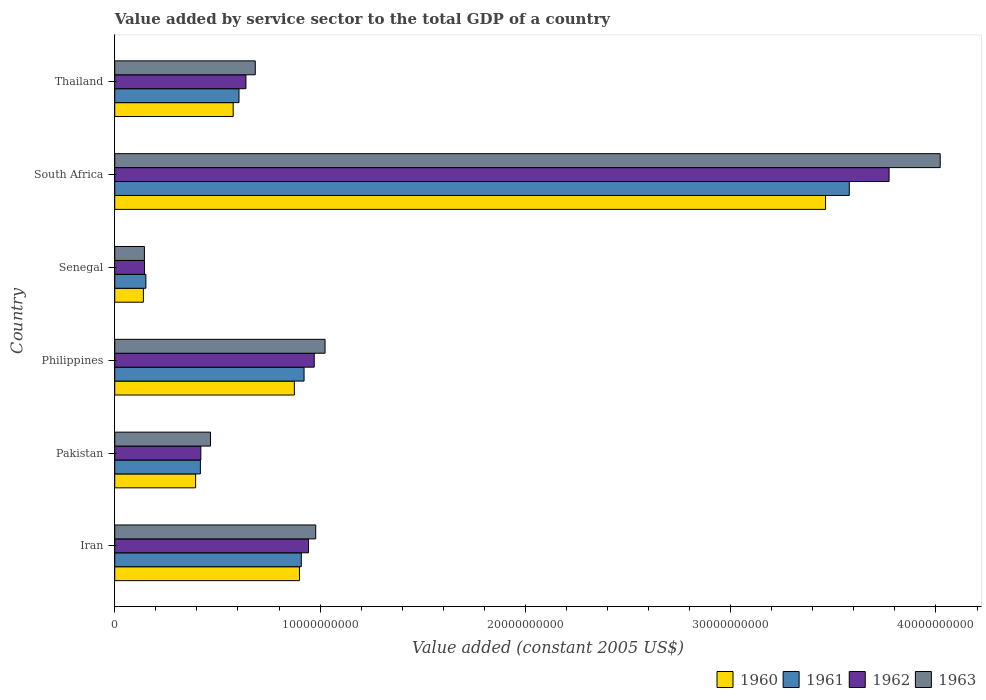How many different coloured bars are there?
Ensure brevity in your answer.  4. What is the label of the 3rd group of bars from the top?
Your answer should be compact. Senegal. What is the value added by service sector in 1963 in Thailand?
Make the answer very short. 6.84e+09. Across all countries, what is the maximum value added by service sector in 1960?
Provide a succinct answer. 3.46e+1. Across all countries, what is the minimum value added by service sector in 1962?
Keep it short and to the point. 1.45e+09. In which country was the value added by service sector in 1960 maximum?
Your answer should be very brief. South Africa. In which country was the value added by service sector in 1962 minimum?
Your answer should be compact. Senegal. What is the total value added by service sector in 1961 in the graph?
Your answer should be very brief. 6.58e+1. What is the difference between the value added by service sector in 1961 in Pakistan and that in Philippines?
Offer a terse response. -5.05e+09. What is the difference between the value added by service sector in 1962 in South Africa and the value added by service sector in 1960 in Philippines?
Provide a short and direct response. 2.90e+1. What is the average value added by service sector in 1963 per country?
Offer a very short reply. 1.22e+1. What is the difference between the value added by service sector in 1962 and value added by service sector in 1961 in Thailand?
Your answer should be very brief. 3.39e+08. In how many countries, is the value added by service sector in 1962 greater than 16000000000 US$?
Your answer should be very brief. 1. What is the ratio of the value added by service sector in 1962 in Pakistan to that in Philippines?
Make the answer very short. 0.43. Is the difference between the value added by service sector in 1962 in Pakistan and Senegal greater than the difference between the value added by service sector in 1961 in Pakistan and Senegal?
Make the answer very short. Yes. What is the difference between the highest and the second highest value added by service sector in 1962?
Give a very brief answer. 2.80e+1. What is the difference between the highest and the lowest value added by service sector in 1960?
Offer a very short reply. 3.32e+1. Is the sum of the value added by service sector in 1961 in Iran and Thailand greater than the maximum value added by service sector in 1960 across all countries?
Give a very brief answer. No. Are all the bars in the graph horizontal?
Ensure brevity in your answer.  Yes. What is the difference between two consecutive major ticks on the X-axis?
Your answer should be compact. 1.00e+1. Are the values on the major ticks of X-axis written in scientific E-notation?
Give a very brief answer. No. Does the graph contain grids?
Ensure brevity in your answer.  No. Where does the legend appear in the graph?
Give a very brief answer. Bottom right. How are the legend labels stacked?
Offer a terse response. Horizontal. What is the title of the graph?
Ensure brevity in your answer.  Value added by service sector to the total GDP of a country. What is the label or title of the X-axis?
Give a very brief answer. Value added (constant 2005 US$). What is the label or title of the Y-axis?
Your answer should be very brief. Country. What is the Value added (constant 2005 US$) of 1960 in Iran?
Provide a short and direct response. 9.00e+09. What is the Value added (constant 2005 US$) in 1961 in Iran?
Ensure brevity in your answer.  9.09e+09. What is the Value added (constant 2005 US$) in 1962 in Iran?
Ensure brevity in your answer.  9.44e+09. What is the Value added (constant 2005 US$) in 1963 in Iran?
Keep it short and to the point. 9.79e+09. What is the Value added (constant 2005 US$) of 1960 in Pakistan?
Your answer should be very brief. 3.94e+09. What is the Value added (constant 2005 US$) in 1961 in Pakistan?
Provide a short and direct response. 4.17e+09. What is the Value added (constant 2005 US$) in 1962 in Pakistan?
Give a very brief answer. 4.19e+09. What is the Value added (constant 2005 US$) in 1963 in Pakistan?
Provide a succinct answer. 4.66e+09. What is the Value added (constant 2005 US$) in 1960 in Philippines?
Your answer should be very brief. 8.75e+09. What is the Value added (constant 2005 US$) in 1961 in Philippines?
Offer a terse response. 9.22e+09. What is the Value added (constant 2005 US$) in 1962 in Philippines?
Keep it short and to the point. 9.72e+09. What is the Value added (constant 2005 US$) of 1963 in Philippines?
Provide a short and direct response. 1.02e+1. What is the Value added (constant 2005 US$) in 1960 in Senegal?
Your answer should be very brief. 1.39e+09. What is the Value added (constant 2005 US$) of 1961 in Senegal?
Make the answer very short. 1.52e+09. What is the Value added (constant 2005 US$) in 1962 in Senegal?
Ensure brevity in your answer.  1.45e+09. What is the Value added (constant 2005 US$) of 1963 in Senegal?
Your response must be concise. 1.44e+09. What is the Value added (constant 2005 US$) of 1960 in South Africa?
Your answer should be very brief. 3.46e+1. What is the Value added (constant 2005 US$) of 1961 in South Africa?
Your response must be concise. 3.58e+1. What is the Value added (constant 2005 US$) of 1962 in South Africa?
Ensure brevity in your answer.  3.77e+1. What is the Value added (constant 2005 US$) in 1963 in South Africa?
Your answer should be very brief. 4.02e+1. What is the Value added (constant 2005 US$) of 1960 in Thailand?
Offer a very short reply. 5.77e+09. What is the Value added (constant 2005 US$) of 1961 in Thailand?
Keep it short and to the point. 6.05e+09. What is the Value added (constant 2005 US$) of 1962 in Thailand?
Give a very brief answer. 6.39e+09. What is the Value added (constant 2005 US$) of 1963 in Thailand?
Offer a very short reply. 6.84e+09. Across all countries, what is the maximum Value added (constant 2005 US$) in 1960?
Provide a short and direct response. 3.46e+1. Across all countries, what is the maximum Value added (constant 2005 US$) in 1961?
Provide a short and direct response. 3.58e+1. Across all countries, what is the maximum Value added (constant 2005 US$) of 1962?
Your response must be concise. 3.77e+1. Across all countries, what is the maximum Value added (constant 2005 US$) in 1963?
Offer a terse response. 4.02e+1. Across all countries, what is the minimum Value added (constant 2005 US$) in 1960?
Keep it short and to the point. 1.39e+09. Across all countries, what is the minimum Value added (constant 2005 US$) in 1961?
Make the answer very short. 1.52e+09. Across all countries, what is the minimum Value added (constant 2005 US$) in 1962?
Give a very brief answer. 1.45e+09. Across all countries, what is the minimum Value added (constant 2005 US$) of 1963?
Provide a succinct answer. 1.44e+09. What is the total Value added (constant 2005 US$) of 1960 in the graph?
Offer a very short reply. 6.35e+1. What is the total Value added (constant 2005 US$) in 1961 in the graph?
Offer a very short reply. 6.58e+1. What is the total Value added (constant 2005 US$) in 1962 in the graph?
Your response must be concise. 6.89e+1. What is the total Value added (constant 2005 US$) in 1963 in the graph?
Ensure brevity in your answer.  7.32e+1. What is the difference between the Value added (constant 2005 US$) of 1960 in Iran and that in Pakistan?
Give a very brief answer. 5.06e+09. What is the difference between the Value added (constant 2005 US$) of 1961 in Iran and that in Pakistan?
Your response must be concise. 4.92e+09. What is the difference between the Value added (constant 2005 US$) in 1962 in Iran and that in Pakistan?
Offer a terse response. 5.24e+09. What is the difference between the Value added (constant 2005 US$) of 1963 in Iran and that in Pakistan?
Your answer should be very brief. 5.12e+09. What is the difference between the Value added (constant 2005 US$) of 1960 in Iran and that in Philippines?
Offer a very short reply. 2.49e+08. What is the difference between the Value added (constant 2005 US$) in 1961 in Iran and that in Philippines?
Give a very brief answer. -1.35e+08. What is the difference between the Value added (constant 2005 US$) of 1962 in Iran and that in Philippines?
Give a very brief answer. -2.80e+08. What is the difference between the Value added (constant 2005 US$) in 1963 in Iran and that in Philippines?
Ensure brevity in your answer.  -4.54e+08. What is the difference between the Value added (constant 2005 US$) in 1960 in Iran and that in Senegal?
Your answer should be compact. 7.60e+09. What is the difference between the Value added (constant 2005 US$) of 1961 in Iran and that in Senegal?
Provide a short and direct response. 7.57e+09. What is the difference between the Value added (constant 2005 US$) of 1962 in Iran and that in Senegal?
Keep it short and to the point. 7.99e+09. What is the difference between the Value added (constant 2005 US$) in 1963 in Iran and that in Senegal?
Offer a terse response. 8.34e+09. What is the difference between the Value added (constant 2005 US$) of 1960 in Iran and that in South Africa?
Provide a short and direct response. -2.56e+1. What is the difference between the Value added (constant 2005 US$) in 1961 in Iran and that in South Africa?
Your answer should be compact. -2.67e+1. What is the difference between the Value added (constant 2005 US$) of 1962 in Iran and that in South Africa?
Provide a short and direct response. -2.83e+1. What is the difference between the Value added (constant 2005 US$) in 1963 in Iran and that in South Africa?
Provide a succinct answer. -3.04e+1. What is the difference between the Value added (constant 2005 US$) of 1960 in Iran and that in Thailand?
Your response must be concise. 3.23e+09. What is the difference between the Value added (constant 2005 US$) of 1961 in Iran and that in Thailand?
Offer a very short reply. 3.03e+09. What is the difference between the Value added (constant 2005 US$) of 1962 in Iran and that in Thailand?
Your answer should be very brief. 3.05e+09. What is the difference between the Value added (constant 2005 US$) of 1963 in Iran and that in Thailand?
Your answer should be compact. 2.94e+09. What is the difference between the Value added (constant 2005 US$) of 1960 in Pakistan and that in Philippines?
Provide a succinct answer. -4.81e+09. What is the difference between the Value added (constant 2005 US$) of 1961 in Pakistan and that in Philippines?
Your answer should be compact. -5.05e+09. What is the difference between the Value added (constant 2005 US$) of 1962 in Pakistan and that in Philippines?
Provide a succinct answer. -5.52e+09. What is the difference between the Value added (constant 2005 US$) of 1963 in Pakistan and that in Philippines?
Your answer should be very brief. -5.58e+09. What is the difference between the Value added (constant 2005 US$) of 1960 in Pakistan and that in Senegal?
Offer a terse response. 2.54e+09. What is the difference between the Value added (constant 2005 US$) of 1961 in Pakistan and that in Senegal?
Provide a short and direct response. 2.65e+09. What is the difference between the Value added (constant 2005 US$) in 1962 in Pakistan and that in Senegal?
Your answer should be very brief. 2.74e+09. What is the difference between the Value added (constant 2005 US$) in 1963 in Pakistan and that in Senegal?
Provide a short and direct response. 3.22e+09. What is the difference between the Value added (constant 2005 US$) in 1960 in Pakistan and that in South Africa?
Provide a succinct answer. -3.07e+1. What is the difference between the Value added (constant 2005 US$) in 1961 in Pakistan and that in South Africa?
Provide a short and direct response. -3.16e+1. What is the difference between the Value added (constant 2005 US$) in 1962 in Pakistan and that in South Africa?
Ensure brevity in your answer.  -3.35e+1. What is the difference between the Value added (constant 2005 US$) in 1963 in Pakistan and that in South Africa?
Offer a very short reply. -3.55e+1. What is the difference between the Value added (constant 2005 US$) of 1960 in Pakistan and that in Thailand?
Your answer should be very brief. -1.83e+09. What is the difference between the Value added (constant 2005 US$) in 1961 in Pakistan and that in Thailand?
Offer a terse response. -1.88e+09. What is the difference between the Value added (constant 2005 US$) in 1962 in Pakistan and that in Thailand?
Ensure brevity in your answer.  -2.20e+09. What is the difference between the Value added (constant 2005 US$) of 1963 in Pakistan and that in Thailand?
Give a very brief answer. -2.18e+09. What is the difference between the Value added (constant 2005 US$) of 1960 in Philippines and that in Senegal?
Your answer should be compact. 7.35e+09. What is the difference between the Value added (constant 2005 US$) of 1961 in Philippines and that in Senegal?
Your response must be concise. 7.70e+09. What is the difference between the Value added (constant 2005 US$) of 1962 in Philippines and that in Senegal?
Keep it short and to the point. 8.27e+09. What is the difference between the Value added (constant 2005 US$) in 1963 in Philippines and that in Senegal?
Give a very brief answer. 8.80e+09. What is the difference between the Value added (constant 2005 US$) in 1960 in Philippines and that in South Africa?
Your response must be concise. -2.59e+1. What is the difference between the Value added (constant 2005 US$) in 1961 in Philippines and that in South Africa?
Your answer should be very brief. -2.66e+1. What is the difference between the Value added (constant 2005 US$) of 1962 in Philippines and that in South Africa?
Your answer should be compact. -2.80e+1. What is the difference between the Value added (constant 2005 US$) in 1963 in Philippines and that in South Africa?
Offer a terse response. -3.00e+1. What is the difference between the Value added (constant 2005 US$) in 1960 in Philippines and that in Thailand?
Your response must be concise. 2.98e+09. What is the difference between the Value added (constant 2005 US$) in 1961 in Philippines and that in Thailand?
Keep it short and to the point. 3.17e+09. What is the difference between the Value added (constant 2005 US$) in 1962 in Philippines and that in Thailand?
Keep it short and to the point. 3.33e+09. What is the difference between the Value added (constant 2005 US$) of 1963 in Philippines and that in Thailand?
Give a very brief answer. 3.40e+09. What is the difference between the Value added (constant 2005 US$) of 1960 in Senegal and that in South Africa?
Provide a succinct answer. -3.32e+1. What is the difference between the Value added (constant 2005 US$) of 1961 in Senegal and that in South Africa?
Ensure brevity in your answer.  -3.43e+1. What is the difference between the Value added (constant 2005 US$) of 1962 in Senegal and that in South Africa?
Offer a very short reply. -3.63e+1. What is the difference between the Value added (constant 2005 US$) in 1963 in Senegal and that in South Africa?
Your answer should be compact. -3.88e+1. What is the difference between the Value added (constant 2005 US$) in 1960 in Senegal and that in Thailand?
Provide a succinct answer. -4.37e+09. What is the difference between the Value added (constant 2005 US$) in 1961 in Senegal and that in Thailand?
Give a very brief answer. -4.53e+09. What is the difference between the Value added (constant 2005 US$) of 1962 in Senegal and that in Thailand?
Make the answer very short. -4.94e+09. What is the difference between the Value added (constant 2005 US$) in 1963 in Senegal and that in Thailand?
Provide a short and direct response. -5.40e+09. What is the difference between the Value added (constant 2005 US$) in 1960 in South Africa and that in Thailand?
Keep it short and to the point. 2.89e+1. What is the difference between the Value added (constant 2005 US$) of 1961 in South Africa and that in Thailand?
Provide a succinct answer. 2.97e+1. What is the difference between the Value added (constant 2005 US$) in 1962 in South Africa and that in Thailand?
Your answer should be compact. 3.13e+1. What is the difference between the Value added (constant 2005 US$) of 1963 in South Africa and that in Thailand?
Offer a very short reply. 3.34e+1. What is the difference between the Value added (constant 2005 US$) in 1960 in Iran and the Value added (constant 2005 US$) in 1961 in Pakistan?
Your response must be concise. 4.83e+09. What is the difference between the Value added (constant 2005 US$) of 1960 in Iran and the Value added (constant 2005 US$) of 1962 in Pakistan?
Your response must be concise. 4.80e+09. What is the difference between the Value added (constant 2005 US$) in 1960 in Iran and the Value added (constant 2005 US$) in 1963 in Pakistan?
Provide a short and direct response. 4.33e+09. What is the difference between the Value added (constant 2005 US$) of 1961 in Iran and the Value added (constant 2005 US$) of 1962 in Pakistan?
Give a very brief answer. 4.89e+09. What is the difference between the Value added (constant 2005 US$) of 1961 in Iran and the Value added (constant 2005 US$) of 1963 in Pakistan?
Your answer should be compact. 4.42e+09. What is the difference between the Value added (constant 2005 US$) in 1962 in Iran and the Value added (constant 2005 US$) in 1963 in Pakistan?
Give a very brief answer. 4.77e+09. What is the difference between the Value added (constant 2005 US$) in 1960 in Iran and the Value added (constant 2005 US$) in 1961 in Philippines?
Give a very brief answer. -2.24e+08. What is the difference between the Value added (constant 2005 US$) in 1960 in Iran and the Value added (constant 2005 US$) in 1962 in Philippines?
Your response must be concise. -7.19e+08. What is the difference between the Value added (constant 2005 US$) in 1960 in Iran and the Value added (constant 2005 US$) in 1963 in Philippines?
Make the answer very short. -1.25e+09. What is the difference between the Value added (constant 2005 US$) in 1961 in Iran and the Value added (constant 2005 US$) in 1962 in Philippines?
Offer a very short reply. -6.30e+08. What is the difference between the Value added (constant 2005 US$) of 1961 in Iran and the Value added (constant 2005 US$) of 1963 in Philippines?
Keep it short and to the point. -1.16e+09. What is the difference between the Value added (constant 2005 US$) in 1962 in Iran and the Value added (constant 2005 US$) in 1963 in Philippines?
Your answer should be compact. -8.07e+08. What is the difference between the Value added (constant 2005 US$) in 1960 in Iran and the Value added (constant 2005 US$) in 1961 in Senegal?
Your answer should be compact. 7.48e+09. What is the difference between the Value added (constant 2005 US$) of 1960 in Iran and the Value added (constant 2005 US$) of 1962 in Senegal?
Your response must be concise. 7.55e+09. What is the difference between the Value added (constant 2005 US$) in 1960 in Iran and the Value added (constant 2005 US$) in 1963 in Senegal?
Make the answer very short. 7.55e+09. What is the difference between the Value added (constant 2005 US$) of 1961 in Iran and the Value added (constant 2005 US$) of 1962 in Senegal?
Provide a succinct answer. 7.64e+09. What is the difference between the Value added (constant 2005 US$) of 1961 in Iran and the Value added (constant 2005 US$) of 1963 in Senegal?
Give a very brief answer. 7.64e+09. What is the difference between the Value added (constant 2005 US$) in 1962 in Iran and the Value added (constant 2005 US$) in 1963 in Senegal?
Make the answer very short. 7.99e+09. What is the difference between the Value added (constant 2005 US$) of 1960 in Iran and the Value added (constant 2005 US$) of 1961 in South Africa?
Provide a succinct answer. -2.68e+1. What is the difference between the Value added (constant 2005 US$) in 1960 in Iran and the Value added (constant 2005 US$) in 1962 in South Africa?
Your answer should be compact. -2.87e+1. What is the difference between the Value added (constant 2005 US$) in 1960 in Iran and the Value added (constant 2005 US$) in 1963 in South Africa?
Your response must be concise. -3.12e+1. What is the difference between the Value added (constant 2005 US$) in 1961 in Iran and the Value added (constant 2005 US$) in 1962 in South Africa?
Keep it short and to the point. -2.86e+1. What is the difference between the Value added (constant 2005 US$) in 1961 in Iran and the Value added (constant 2005 US$) in 1963 in South Africa?
Make the answer very short. -3.11e+1. What is the difference between the Value added (constant 2005 US$) of 1962 in Iran and the Value added (constant 2005 US$) of 1963 in South Africa?
Offer a very short reply. -3.08e+1. What is the difference between the Value added (constant 2005 US$) of 1960 in Iran and the Value added (constant 2005 US$) of 1961 in Thailand?
Your response must be concise. 2.95e+09. What is the difference between the Value added (constant 2005 US$) of 1960 in Iran and the Value added (constant 2005 US$) of 1962 in Thailand?
Ensure brevity in your answer.  2.61e+09. What is the difference between the Value added (constant 2005 US$) in 1960 in Iran and the Value added (constant 2005 US$) in 1963 in Thailand?
Your response must be concise. 2.15e+09. What is the difference between the Value added (constant 2005 US$) in 1961 in Iran and the Value added (constant 2005 US$) in 1962 in Thailand?
Provide a short and direct response. 2.70e+09. What is the difference between the Value added (constant 2005 US$) of 1961 in Iran and the Value added (constant 2005 US$) of 1963 in Thailand?
Give a very brief answer. 2.24e+09. What is the difference between the Value added (constant 2005 US$) in 1962 in Iran and the Value added (constant 2005 US$) in 1963 in Thailand?
Your response must be concise. 2.59e+09. What is the difference between the Value added (constant 2005 US$) of 1960 in Pakistan and the Value added (constant 2005 US$) of 1961 in Philippines?
Offer a very short reply. -5.28e+09. What is the difference between the Value added (constant 2005 US$) of 1960 in Pakistan and the Value added (constant 2005 US$) of 1962 in Philippines?
Offer a very short reply. -5.78e+09. What is the difference between the Value added (constant 2005 US$) in 1960 in Pakistan and the Value added (constant 2005 US$) in 1963 in Philippines?
Offer a terse response. -6.30e+09. What is the difference between the Value added (constant 2005 US$) in 1961 in Pakistan and the Value added (constant 2005 US$) in 1962 in Philippines?
Provide a short and direct response. -5.55e+09. What is the difference between the Value added (constant 2005 US$) in 1961 in Pakistan and the Value added (constant 2005 US$) in 1963 in Philippines?
Keep it short and to the point. -6.07e+09. What is the difference between the Value added (constant 2005 US$) of 1962 in Pakistan and the Value added (constant 2005 US$) of 1963 in Philippines?
Your answer should be very brief. -6.05e+09. What is the difference between the Value added (constant 2005 US$) of 1960 in Pakistan and the Value added (constant 2005 US$) of 1961 in Senegal?
Offer a terse response. 2.42e+09. What is the difference between the Value added (constant 2005 US$) in 1960 in Pakistan and the Value added (constant 2005 US$) in 1962 in Senegal?
Give a very brief answer. 2.49e+09. What is the difference between the Value added (constant 2005 US$) in 1960 in Pakistan and the Value added (constant 2005 US$) in 1963 in Senegal?
Offer a very short reply. 2.49e+09. What is the difference between the Value added (constant 2005 US$) of 1961 in Pakistan and the Value added (constant 2005 US$) of 1962 in Senegal?
Provide a succinct answer. 2.72e+09. What is the difference between the Value added (constant 2005 US$) of 1961 in Pakistan and the Value added (constant 2005 US$) of 1963 in Senegal?
Provide a succinct answer. 2.73e+09. What is the difference between the Value added (constant 2005 US$) of 1962 in Pakistan and the Value added (constant 2005 US$) of 1963 in Senegal?
Your answer should be very brief. 2.75e+09. What is the difference between the Value added (constant 2005 US$) in 1960 in Pakistan and the Value added (constant 2005 US$) in 1961 in South Africa?
Make the answer very short. -3.18e+1. What is the difference between the Value added (constant 2005 US$) of 1960 in Pakistan and the Value added (constant 2005 US$) of 1962 in South Africa?
Offer a very short reply. -3.38e+1. What is the difference between the Value added (constant 2005 US$) of 1960 in Pakistan and the Value added (constant 2005 US$) of 1963 in South Africa?
Ensure brevity in your answer.  -3.63e+1. What is the difference between the Value added (constant 2005 US$) in 1961 in Pakistan and the Value added (constant 2005 US$) in 1962 in South Africa?
Offer a very short reply. -3.35e+1. What is the difference between the Value added (constant 2005 US$) of 1961 in Pakistan and the Value added (constant 2005 US$) of 1963 in South Africa?
Offer a very short reply. -3.60e+1. What is the difference between the Value added (constant 2005 US$) of 1962 in Pakistan and the Value added (constant 2005 US$) of 1963 in South Africa?
Provide a succinct answer. -3.60e+1. What is the difference between the Value added (constant 2005 US$) in 1960 in Pakistan and the Value added (constant 2005 US$) in 1961 in Thailand?
Offer a terse response. -2.11e+09. What is the difference between the Value added (constant 2005 US$) in 1960 in Pakistan and the Value added (constant 2005 US$) in 1962 in Thailand?
Keep it short and to the point. -2.45e+09. What is the difference between the Value added (constant 2005 US$) in 1960 in Pakistan and the Value added (constant 2005 US$) in 1963 in Thailand?
Give a very brief answer. -2.91e+09. What is the difference between the Value added (constant 2005 US$) in 1961 in Pakistan and the Value added (constant 2005 US$) in 1962 in Thailand?
Provide a short and direct response. -2.22e+09. What is the difference between the Value added (constant 2005 US$) in 1961 in Pakistan and the Value added (constant 2005 US$) in 1963 in Thailand?
Provide a short and direct response. -2.67e+09. What is the difference between the Value added (constant 2005 US$) of 1962 in Pakistan and the Value added (constant 2005 US$) of 1963 in Thailand?
Ensure brevity in your answer.  -2.65e+09. What is the difference between the Value added (constant 2005 US$) of 1960 in Philippines and the Value added (constant 2005 US$) of 1961 in Senegal?
Keep it short and to the point. 7.23e+09. What is the difference between the Value added (constant 2005 US$) of 1960 in Philippines and the Value added (constant 2005 US$) of 1962 in Senegal?
Provide a short and direct response. 7.30e+09. What is the difference between the Value added (constant 2005 US$) in 1960 in Philippines and the Value added (constant 2005 US$) in 1963 in Senegal?
Your response must be concise. 7.30e+09. What is the difference between the Value added (constant 2005 US$) of 1961 in Philippines and the Value added (constant 2005 US$) of 1962 in Senegal?
Your answer should be very brief. 7.77e+09. What is the difference between the Value added (constant 2005 US$) in 1961 in Philippines and the Value added (constant 2005 US$) in 1963 in Senegal?
Keep it short and to the point. 7.78e+09. What is the difference between the Value added (constant 2005 US$) in 1962 in Philippines and the Value added (constant 2005 US$) in 1963 in Senegal?
Make the answer very short. 8.27e+09. What is the difference between the Value added (constant 2005 US$) in 1960 in Philippines and the Value added (constant 2005 US$) in 1961 in South Africa?
Keep it short and to the point. -2.70e+1. What is the difference between the Value added (constant 2005 US$) of 1960 in Philippines and the Value added (constant 2005 US$) of 1962 in South Africa?
Offer a very short reply. -2.90e+1. What is the difference between the Value added (constant 2005 US$) of 1960 in Philippines and the Value added (constant 2005 US$) of 1963 in South Africa?
Your answer should be compact. -3.15e+1. What is the difference between the Value added (constant 2005 US$) of 1961 in Philippines and the Value added (constant 2005 US$) of 1962 in South Africa?
Make the answer very short. -2.85e+1. What is the difference between the Value added (constant 2005 US$) in 1961 in Philippines and the Value added (constant 2005 US$) in 1963 in South Africa?
Keep it short and to the point. -3.10e+1. What is the difference between the Value added (constant 2005 US$) in 1962 in Philippines and the Value added (constant 2005 US$) in 1963 in South Africa?
Provide a succinct answer. -3.05e+1. What is the difference between the Value added (constant 2005 US$) in 1960 in Philippines and the Value added (constant 2005 US$) in 1961 in Thailand?
Offer a very short reply. 2.70e+09. What is the difference between the Value added (constant 2005 US$) of 1960 in Philippines and the Value added (constant 2005 US$) of 1962 in Thailand?
Offer a terse response. 2.36e+09. What is the difference between the Value added (constant 2005 US$) of 1960 in Philippines and the Value added (constant 2005 US$) of 1963 in Thailand?
Your response must be concise. 1.90e+09. What is the difference between the Value added (constant 2005 US$) in 1961 in Philippines and the Value added (constant 2005 US$) in 1962 in Thailand?
Your response must be concise. 2.83e+09. What is the difference between the Value added (constant 2005 US$) in 1961 in Philippines and the Value added (constant 2005 US$) in 1963 in Thailand?
Offer a terse response. 2.38e+09. What is the difference between the Value added (constant 2005 US$) of 1962 in Philippines and the Value added (constant 2005 US$) of 1963 in Thailand?
Make the answer very short. 2.87e+09. What is the difference between the Value added (constant 2005 US$) of 1960 in Senegal and the Value added (constant 2005 US$) of 1961 in South Africa?
Offer a very short reply. -3.44e+1. What is the difference between the Value added (constant 2005 US$) in 1960 in Senegal and the Value added (constant 2005 US$) in 1962 in South Africa?
Offer a terse response. -3.63e+1. What is the difference between the Value added (constant 2005 US$) in 1960 in Senegal and the Value added (constant 2005 US$) in 1963 in South Africa?
Provide a short and direct response. -3.88e+1. What is the difference between the Value added (constant 2005 US$) of 1961 in Senegal and the Value added (constant 2005 US$) of 1962 in South Africa?
Give a very brief answer. -3.62e+1. What is the difference between the Value added (constant 2005 US$) of 1961 in Senegal and the Value added (constant 2005 US$) of 1963 in South Africa?
Provide a short and direct response. -3.87e+1. What is the difference between the Value added (constant 2005 US$) of 1962 in Senegal and the Value added (constant 2005 US$) of 1963 in South Africa?
Give a very brief answer. -3.88e+1. What is the difference between the Value added (constant 2005 US$) of 1960 in Senegal and the Value added (constant 2005 US$) of 1961 in Thailand?
Offer a terse response. -4.66e+09. What is the difference between the Value added (constant 2005 US$) of 1960 in Senegal and the Value added (constant 2005 US$) of 1962 in Thailand?
Give a very brief answer. -5.00e+09. What is the difference between the Value added (constant 2005 US$) of 1960 in Senegal and the Value added (constant 2005 US$) of 1963 in Thailand?
Your response must be concise. -5.45e+09. What is the difference between the Value added (constant 2005 US$) of 1961 in Senegal and the Value added (constant 2005 US$) of 1962 in Thailand?
Your response must be concise. -4.87e+09. What is the difference between the Value added (constant 2005 US$) of 1961 in Senegal and the Value added (constant 2005 US$) of 1963 in Thailand?
Keep it short and to the point. -5.33e+09. What is the difference between the Value added (constant 2005 US$) of 1962 in Senegal and the Value added (constant 2005 US$) of 1963 in Thailand?
Ensure brevity in your answer.  -5.39e+09. What is the difference between the Value added (constant 2005 US$) in 1960 in South Africa and the Value added (constant 2005 US$) in 1961 in Thailand?
Keep it short and to the point. 2.86e+1. What is the difference between the Value added (constant 2005 US$) in 1960 in South Africa and the Value added (constant 2005 US$) in 1962 in Thailand?
Keep it short and to the point. 2.82e+1. What is the difference between the Value added (constant 2005 US$) of 1960 in South Africa and the Value added (constant 2005 US$) of 1963 in Thailand?
Offer a very short reply. 2.78e+1. What is the difference between the Value added (constant 2005 US$) in 1961 in South Africa and the Value added (constant 2005 US$) in 1962 in Thailand?
Keep it short and to the point. 2.94e+1. What is the difference between the Value added (constant 2005 US$) in 1961 in South Africa and the Value added (constant 2005 US$) in 1963 in Thailand?
Give a very brief answer. 2.89e+1. What is the difference between the Value added (constant 2005 US$) of 1962 in South Africa and the Value added (constant 2005 US$) of 1963 in Thailand?
Make the answer very short. 3.09e+1. What is the average Value added (constant 2005 US$) of 1960 per country?
Your answer should be compact. 1.06e+1. What is the average Value added (constant 2005 US$) of 1961 per country?
Provide a succinct answer. 1.10e+1. What is the average Value added (constant 2005 US$) of 1962 per country?
Keep it short and to the point. 1.15e+1. What is the average Value added (constant 2005 US$) of 1963 per country?
Offer a terse response. 1.22e+1. What is the difference between the Value added (constant 2005 US$) in 1960 and Value added (constant 2005 US$) in 1961 in Iran?
Your response must be concise. -8.88e+07. What is the difference between the Value added (constant 2005 US$) of 1960 and Value added (constant 2005 US$) of 1962 in Iran?
Make the answer very short. -4.39e+08. What is the difference between the Value added (constant 2005 US$) in 1960 and Value added (constant 2005 US$) in 1963 in Iran?
Your answer should be very brief. -7.91e+08. What is the difference between the Value added (constant 2005 US$) of 1961 and Value added (constant 2005 US$) of 1962 in Iran?
Your response must be concise. -3.50e+08. What is the difference between the Value added (constant 2005 US$) in 1961 and Value added (constant 2005 US$) in 1963 in Iran?
Provide a short and direct response. -7.02e+08. What is the difference between the Value added (constant 2005 US$) of 1962 and Value added (constant 2005 US$) of 1963 in Iran?
Your response must be concise. -3.52e+08. What is the difference between the Value added (constant 2005 US$) in 1960 and Value added (constant 2005 US$) in 1961 in Pakistan?
Provide a short and direct response. -2.32e+08. What is the difference between the Value added (constant 2005 US$) of 1960 and Value added (constant 2005 US$) of 1962 in Pakistan?
Make the answer very short. -2.54e+08. What is the difference between the Value added (constant 2005 US$) of 1960 and Value added (constant 2005 US$) of 1963 in Pakistan?
Ensure brevity in your answer.  -7.25e+08. What is the difference between the Value added (constant 2005 US$) of 1961 and Value added (constant 2005 US$) of 1962 in Pakistan?
Keep it short and to the point. -2.26e+07. What is the difference between the Value added (constant 2005 US$) in 1961 and Value added (constant 2005 US$) in 1963 in Pakistan?
Your answer should be very brief. -4.93e+08. What is the difference between the Value added (constant 2005 US$) in 1962 and Value added (constant 2005 US$) in 1963 in Pakistan?
Provide a short and direct response. -4.71e+08. What is the difference between the Value added (constant 2005 US$) of 1960 and Value added (constant 2005 US$) of 1961 in Philippines?
Your answer should be very brief. -4.73e+08. What is the difference between the Value added (constant 2005 US$) of 1960 and Value added (constant 2005 US$) of 1962 in Philippines?
Make the answer very short. -9.68e+08. What is the difference between the Value added (constant 2005 US$) of 1960 and Value added (constant 2005 US$) of 1963 in Philippines?
Your answer should be very brief. -1.49e+09. What is the difference between the Value added (constant 2005 US$) in 1961 and Value added (constant 2005 US$) in 1962 in Philippines?
Your answer should be very brief. -4.95e+08. What is the difference between the Value added (constant 2005 US$) in 1961 and Value added (constant 2005 US$) in 1963 in Philippines?
Ensure brevity in your answer.  -1.02e+09. What is the difference between the Value added (constant 2005 US$) of 1962 and Value added (constant 2005 US$) of 1963 in Philippines?
Offer a very short reply. -5.27e+08. What is the difference between the Value added (constant 2005 US$) in 1960 and Value added (constant 2005 US$) in 1961 in Senegal?
Make the answer very short. -1.22e+08. What is the difference between the Value added (constant 2005 US$) in 1960 and Value added (constant 2005 US$) in 1962 in Senegal?
Your response must be concise. -5.52e+07. What is the difference between the Value added (constant 2005 US$) of 1960 and Value added (constant 2005 US$) of 1963 in Senegal?
Keep it short and to the point. -4.94e+07. What is the difference between the Value added (constant 2005 US$) in 1961 and Value added (constant 2005 US$) in 1962 in Senegal?
Give a very brief answer. 6.67e+07. What is the difference between the Value added (constant 2005 US$) of 1961 and Value added (constant 2005 US$) of 1963 in Senegal?
Keep it short and to the point. 7.25e+07. What is the difference between the Value added (constant 2005 US$) in 1962 and Value added (constant 2005 US$) in 1963 in Senegal?
Provide a short and direct response. 5.77e+06. What is the difference between the Value added (constant 2005 US$) of 1960 and Value added (constant 2005 US$) of 1961 in South Africa?
Provide a succinct answer. -1.16e+09. What is the difference between the Value added (constant 2005 US$) of 1960 and Value added (constant 2005 US$) of 1962 in South Africa?
Make the answer very short. -3.09e+09. What is the difference between the Value added (constant 2005 US$) in 1960 and Value added (constant 2005 US$) in 1963 in South Africa?
Make the answer very short. -5.58e+09. What is the difference between the Value added (constant 2005 US$) of 1961 and Value added (constant 2005 US$) of 1962 in South Africa?
Offer a very short reply. -1.94e+09. What is the difference between the Value added (constant 2005 US$) of 1961 and Value added (constant 2005 US$) of 1963 in South Africa?
Offer a terse response. -4.43e+09. What is the difference between the Value added (constant 2005 US$) in 1962 and Value added (constant 2005 US$) in 1963 in South Africa?
Keep it short and to the point. -2.49e+09. What is the difference between the Value added (constant 2005 US$) of 1960 and Value added (constant 2005 US$) of 1961 in Thailand?
Your answer should be very brief. -2.83e+08. What is the difference between the Value added (constant 2005 US$) in 1960 and Value added (constant 2005 US$) in 1962 in Thailand?
Offer a very short reply. -6.21e+08. What is the difference between the Value added (constant 2005 US$) in 1960 and Value added (constant 2005 US$) in 1963 in Thailand?
Give a very brief answer. -1.08e+09. What is the difference between the Value added (constant 2005 US$) in 1961 and Value added (constant 2005 US$) in 1962 in Thailand?
Give a very brief answer. -3.39e+08. What is the difference between the Value added (constant 2005 US$) of 1961 and Value added (constant 2005 US$) of 1963 in Thailand?
Provide a short and direct response. -7.93e+08. What is the difference between the Value added (constant 2005 US$) of 1962 and Value added (constant 2005 US$) of 1963 in Thailand?
Provide a short and direct response. -4.54e+08. What is the ratio of the Value added (constant 2005 US$) of 1960 in Iran to that in Pakistan?
Offer a terse response. 2.28. What is the ratio of the Value added (constant 2005 US$) in 1961 in Iran to that in Pakistan?
Provide a short and direct response. 2.18. What is the ratio of the Value added (constant 2005 US$) of 1962 in Iran to that in Pakistan?
Offer a very short reply. 2.25. What is the ratio of the Value added (constant 2005 US$) in 1963 in Iran to that in Pakistan?
Offer a terse response. 2.1. What is the ratio of the Value added (constant 2005 US$) in 1960 in Iran to that in Philippines?
Make the answer very short. 1.03. What is the ratio of the Value added (constant 2005 US$) in 1961 in Iran to that in Philippines?
Make the answer very short. 0.99. What is the ratio of the Value added (constant 2005 US$) in 1962 in Iran to that in Philippines?
Keep it short and to the point. 0.97. What is the ratio of the Value added (constant 2005 US$) of 1963 in Iran to that in Philippines?
Provide a short and direct response. 0.96. What is the ratio of the Value added (constant 2005 US$) in 1960 in Iran to that in Senegal?
Make the answer very short. 6.45. What is the ratio of the Value added (constant 2005 US$) in 1961 in Iran to that in Senegal?
Your answer should be very brief. 5.99. What is the ratio of the Value added (constant 2005 US$) of 1962 in Iran to that in Senegal?
Provide a succinct answer. 6.51. What is the ratio of the Value added (constant 2005 US$) in 1963 in Iran to that in Senegal?
Provide a succinct answer. 6.78. What is the ratio of the Value added (constant 2005 US$) in 1960 in Iran to that in South Africa?
Provide a short and direct response. 0.26. What is the ratio of the Value added (constant 2005 US$) of 1961 in Iran to that in South Africa?
Offer a very short reply. 0.25. What is the ratio of the Value added (constant 2005 US$) in 1962 in Iran to that in South Africa?
Your response must be concise. 0.25. What is the ratio of the Value added (constant 2005 US$) in 1963 in Iran to that in South Africa?
Give a very brief answer. 0.24. What is the ratio of the Value added (constant 2005 US$) in 1960 in Iran to that in Thailand?
Provide a succinct answer. 1.56. What is the ratio of the Value added (constant 2005 US$) in 1961 in Iran to that in Thailand?
Ensure brevity in your answer.  1.5. What is the ratio of the Value added (constant 2005 US$) of 1962 in Iran to that in Thailand?
Provide a short and direct response. 1.48. What is the ratio of the Value added (constant 2005 US$) in 1963 in Iran to that in Thailand?
Offer a very short reply. 1.43. What is the ratio of the Value added (constant 2005 US$) in 1960 in Pakistan to that in Philippines?
Make the answer very short. 0.45. What is the ratio of the Value added (constant 2005 US$) in 1961 in Pakistan to that in Philippines?
Offer a very short reply. 0.45. What is the ratio of the Value added (constant 2005 US$) of 1962 in Pakistan to that in Philippines?
Give a very brief answer. 0.43. What is the ratio of the Value added (constant 2005 US$) in 1963 in Pakistan to that in Philippines?
Offer a terse response. 0.46. What is the ratio of the Value added (constant 2005 US$) in 1960 in Pakistan to that in Senegal?
Give a very brief answer. 2.82. What is the ratio of the Value added (constant 2005 US$) of 1961 in Pakistan to that in Senegal?
Keep it short and to the point. 2.75. What is the ratio of the Value added (constant 2005 US$) of 1962 in Pakistan to that in Senegal?
Make the answer very short. 2.89. What is the ratio of the Value added (constant 2005 US$) of 1963 in Pakistan to that in Senegal?
Offer a very short reply. 3.23. What is the ratio of the Value added (constant 2005 US$) in 1960 in Pakistan to that in South Africa?
Ensure brevity in your answer.  0.11. What is the ratio of the Value added (constant 2005 US$) of 1961 in Pakistan to that in South Africa?
Offer a terse response. 0.12. What is the ratio of the Value added (constant 2005 US$) of 1962 in Pakistan to that in South Africa?
Make the answer very short. 0.11. What is the ratio of the Value added (constant 2005 US$) of 1963 in Pakistan to that in South Africa?
Offer a very short reply. 0.12. What is the ratio of the Value added (constant 2005 US$) of 1960 in Pakistan to that in Thailand?
Offer a terse response. 0.68. What is the ratio of the Value added (constant 2005 US$) of 1961 in Pakistan to that in Thailand?
Offer a terse response. 0.69. What is the ratio of the Value added (constant 2005 US$) in 1962 in Pakistan to that in Thailand?
Provide a succinct answer. 0.66. What is the ratio of the Value added (constant 2005 US$) in 1963 in Pakistan to that in Thailand?
Your answer should be very brief. 0.68. What is the ratio of the Value added (constant 2005 US$) in 1960 in Philippines to that in Senegal?
Keep it short and to the point. 6.27. What is the ratio of the Value added (constant 2005 US$) of 1961 in Philippines to that in Senegal?
Provide a short and direct response. 6.08. What is the ratio of the Value added (constant 2005 US$) in 1962 in Philippines to that in Senegal?
Provide a succinct answer. 6.7. What is the ratio of the Value added (constant 2005 US$) of 1963 in Philippines to that in Senegal?
Ensure brevity in your answer.  7.09. What is the ratio of the Value added (constant 2005 US$) in 1960 in Philippines to that in South Africa?
Provide a succinct answer. 0.25. What is the ratio of the Value added (constant 2005 US$) in 1961 in Philippines to that in South Africa?
Ensure brevity in your answer.  0.26. What is the ratio of the Value added (constant 2005 US$) in 1962 in Philippines to that in South Africa?
Offer a terse response. 0.26. What is the ratio of the Value added (constant 2005 US$) of 1963 in Philippines to that in South Africa?
Provide a succinct answer. 0.25. What is the ratio of the Value added (constant 2005 US$) in 1960 in Philippines to that in Thailand?
Provide a short and direct response. 1.52. What is the ratio of the Value added (constant 2005 US$) in 1961 in Philippines to that in Thailand?
Provide a succinct answer. 1.52. What is the ratio of the Value added (constant 2005 US$) in 1962 in Philippines to that in Thailand?
Your response must be concise. 1.52. What is the ratio of the Value added (constant 2005 US$) in 1963 in Philippines to that in Thailand?
Your answer should be very brief. 1.5. What is the ratio of the Value added (constant 2005 US$) in 1960 in Senegal to that in South Africa?
Your response must be concise. 0.04. What is the ratio of the Value added (constant 2005 US$) in 1961 in Senegal to that in South Africa?
Your response must be concise. 0.04. What is the ratio of the Value added (constant 2005 US$) of 1962 in Senegal to that in South Africa?
Your response must be concise. 0.04. What is the ratio of the Value added (constant 2005 US$) in 1963 in Senegal to that in South Africa?
Your answer should be very brief. 0.04. What is the ratio of the Value added (constant 2005 US$) in 1960 in Senegal to that in Thailand?
Give a very brief answer. 0.24. What is the ratio of the Value added (constant 2005 US$) in 1961 in Senegal to that in Thailand?
Offer a terse response. 0.25. What is the ratio of the Value added (constant 2005 US$) in 1962 in Senegal to that in Thailand?
Provide a succinct answer. 0.23. What is the ratio of the Value added (constant 2005 US$) of 1963 in Senegal to that in Thailand?
Ensure brevity in your answer.  0.21. What is the ratio of the Value added (constant 2005 US$) in 1960 in South Africa to that in Thailand?
Your answer should be very brief. 6. What is the ratio of the Value added (constant 2005 US$) in 1961 in South Africa to that in Thailand?
Make the answer very short. 5.91. What is the ratio of the Value added (constant 2005 US$) in 1962 in South Africa to that in Thailand?
Provide a succinct answer. 5.9. What is the ratio of the Value added (constant 2005 US$) of 1963 in South Africa to that in Thailand?
Your response must be concise. 5.87. What is the difference between the highest and the second highest Value added (constant 2005 US$) of 1960?
Keep it short and to the point. 2.56e+1. What is the difference between the highest and the second highest Value added (constant 2005 US$) in 1961?
Keep it short and to the point. 2.66e+1. What is the difference between the highest and the second highest Value added (constant 2005 US$) in 1962?
Give a very brief answer. 2.80e+1. What is the difference between the highest and the second highest Value added (constant 2005 US$) of 1963?
Your answer should be very brief. 3.00e+1. What is the difference between the highest and the lowest Value added (constant 2005 US$) of 1960?
Keep it short and to the point. 3.32e+1. What is the difference between the highest and the lowest Value added (constant 2005 US$) of 1961?
Your answer should be compact. 3.43e+1. What is the difference between the highest and the lowest Value added (constant 2005 US$) in 1962?
Your answer should be compact. 3.63e+1. What is the difference between the highest and the lowest Value added (constant 2005 US$) of 1963?
Provide a succinct answer. 3.88e+1. 